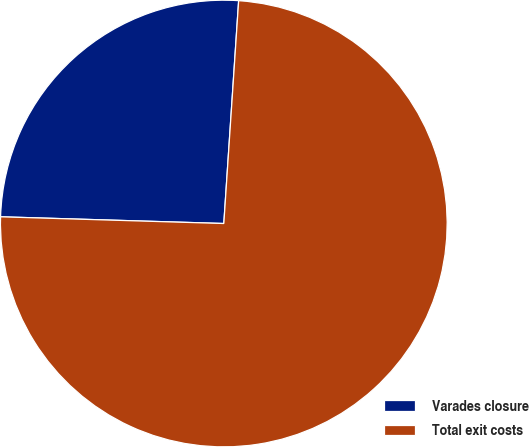Convert chart to OTSL. <chart><loc_0><loc_0><loc_500><loc_500><pie_chart><fcel>Varades closure<fcel>Total exit costs<nl><fcel>25.58%<fcel>74.42%<nl></chart> 